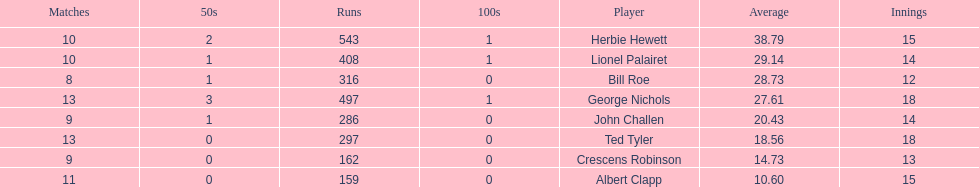Which player had the least amount of runs? Albert Clapp. 